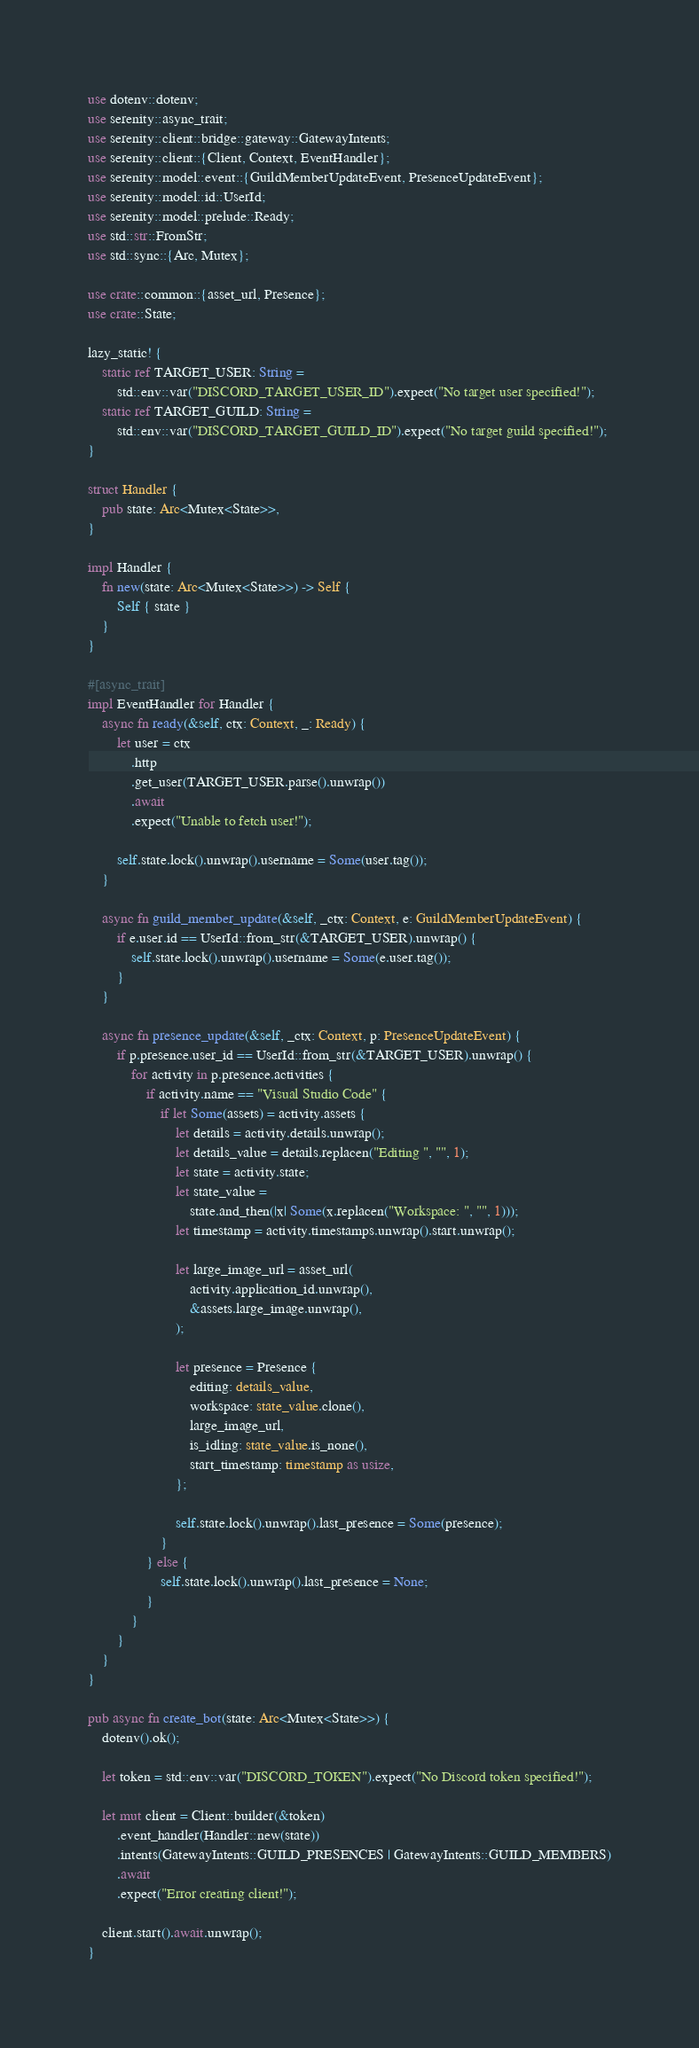<code> <loc_0><loc_0><loc_500><loc_500><_Rust_>use dotenv::dotenv;
use serenity::async_trait;
use serenity::client::bridge::gateway::GatewayIntents;
use serenity::client::{Client, Context, EventHandler};
use serenity::model::event::{GuildMemberUpdateEvent, PresenceUpdateEvent};
use serenity::model::id::UserId;
use serenity::model::prelude::Ready;
use std::str::FromStr;
use std::sync::{Arc, Mutex};

use crate::common::{asset_url, Presence};
use crate::State;

lazy_static! {
    static ref TARGET_USER: String =
        std::env::var("DISCORD_TARGET_USER_ID").expect("No target user specified!");
    static ref TARGET_GUILD: String =
        std::env::var("DISCORD_TARGET_GUILD_ID").expect("No target guild specified!");
}

struct Handler {
    pub state: Arc<Mutex<State>>,
}

impl Handler {
    fn new(state: Arc<Mutex<State>>) -> Self {
        Self { state }
    }
}

#[async_trait]
impl EventHandler for Handler {
    async fn ready(&self, ctx: Context, _: Ready) {
        let user = ctx
            .http
            .get_user(TARGET_USER.parse().unwrap())
            .await
            .expect("Unable to fetch user!");

        self.state.lock().unwrap().username = Some(user.tag());
    }

    async fn guild_member_update(&self, _ctx: Context, e: GuildMemberUpdateEvent) {
        if e.user.id == UserId::from_str(&TARGET_USER).unwrap() {
            self.state.lock().unwrap().username = Some(e.user.tag());
        }
    }

    async fn presence_update(&self, _ctx: Context, p: PresenceUpdateEvent) {
        if p.presence.user_id == UserId::from_str(&TARGET_USER).unwrap() {
            for activity in p.presence.activities {
                if activity.name == "Visual Studio Code" {
                    if let Some(assets) = activity.assets {
                        let details = activity.details.unwrap();
                        let details_value = details.replacen("Editing ", "", 1);
                        let state = activity.state;
                        let state_value =
                            state.and_then(|x| Some(x.replacen("Workspace: ", "", 1)));
                        let timestamp = activity.timestamps.unwrap().start.unwrap();

                        let large_image_url = asset_url(
                            activity.application_id.unwrap(),
                            &assets.large_image.unwrap(),
                        );

                        let presence = Presence {
                            editing: details_value,
                            workspace: state_value.clone(),
                            large_image_url,
                            is_idling: state_value.is_none(),
                            start_timestamp: timestamp as usize,
                        };

                        self.state.lock().unwrap().last_presence = Some(presence);
                    }
                } else {
                    self.state.lock().unwrap().last_presence = None;
                }
            }
        }
    }
}

pub async fn create_bot(state: Arc<Mutex<State>>) {
    dotenv().ok();

    let token = std::env::var("DISCORD_TOKEN").expect("No Discord token specified!");

    let mut client = Client::builder(&token)
        .event_handler(Handler::new(state))
        .intents(GatewayIntents::GUILD_PRESENCES | GatewayIntents::GUILD_MEMBERS)
        .await
        .expect("Error creating client!");

    client.start().await.unwrap();
}
</code> 